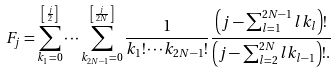Convert formula to latex. <formula><loc_0><loc_0><loc_500><loc_500>F _ { j } = \sum _ { k _ { 1 } = 0 } ^ { \left [ \frac { j } { 2 } \right ] } \cdots \sum _ { k _ { 2 N - 1 } = 0 } ^ { \left [ \frac { j } { 2 N } \right ] } \frac { 1 } { k _ { 1 } ! \cdots k _ { 2 N - 1 } ! } \frac { \left ( j - \sum _ { l = 1 } ^ { 2 N - 1 } l k _ { l } \right ) ! } { \left ( j - \sum _ { l = 2 } ^ { 2 N } l k _ { l - 1 } \right ) ! . }</formula> 